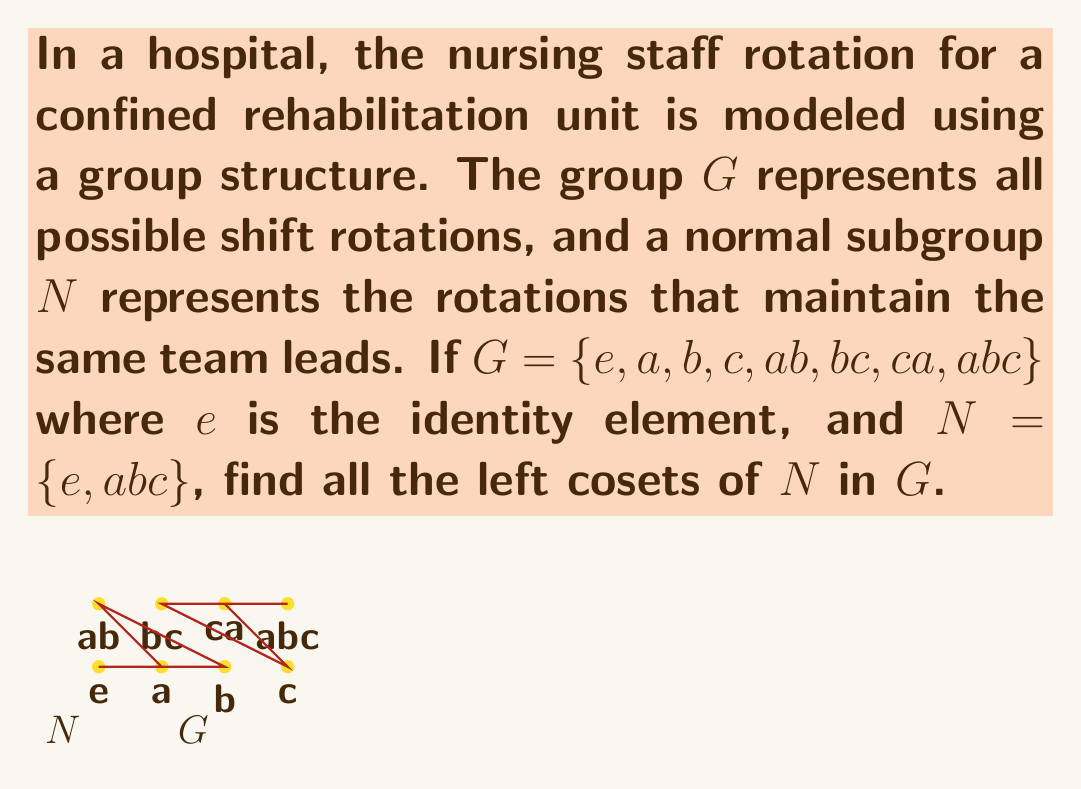What is the answer to this math problem? To find the left cosets of $N$ in $G$, we need to multiply each element of $G$ by $N$ from the left. Since $N = \{e, abc\}$, each coset will have two elements.

1) First coset: $eN = \{e \cdot e, e \cdot abc\} = \{e, abc\} = N$

2) Second coset: $aN = \{a \cdot e, a \cdot abc\} = \{a, a \cdot abc\} = \{a, ca\}$

3) Third coset: $bN = \{b \cdot e, b \cdot abc\} = \{b, b \cdot abc\} = \{b, ab\}$

4) Fourth coset: $cN = \{c \cdot e, c \cdot abc\} = \{c, c \cdot abc\} = \{c, bc\}$

Note that:
- $(ab)N = a(bN) = a\{b, ab\} = \{ab, a\} = \{ab, ca\} = aN$
- $(bc)N = b(cN) = b\{c, bc\} = \{bc, b\} = \{bc, ab\} = bN$
- $(ca)N = c(aN) = c\{a, ca\} = \{ca, c\} = \{ca, bc\} = cN$
- $(abc)N = a(bcN) = a\{bc, c\} = \{abc, a\} = \{abc, e\} = N$

Therefore, we have found all distinct left cosets of $N$ in $G$.
Answer: $\{e, abc\}$, $\{a, ca\}$, $\{b, ab\}$, $\{c, bc\}$ 